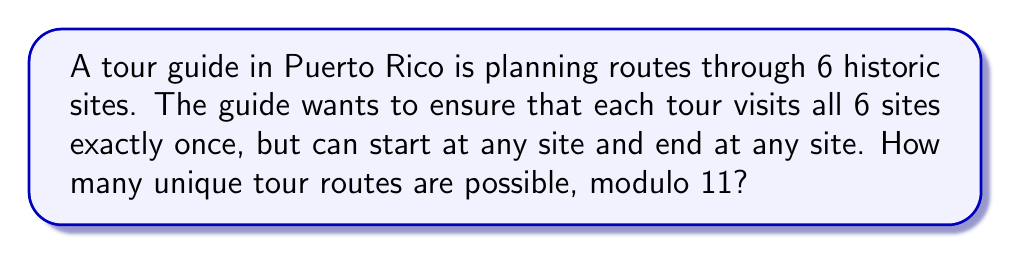Can you solve this math problem? Let's approach this step-by-step:

1) First, we need to calculate the total number of possible routes without considering the modulo:

   - There are 6! ways to arrange 6 sites in a line.
   - However, since the tour can start at any site, we need to divide by 6 (as each unique tour is counted 6 times, once starting from each site).

   So, the total number of unique routes is: $\frac{6!}{6} = 5!$

2) Now, let's calculate 5!:

   $5! = 5 \times 4 \times 3 \times 2 \times 1 = 120$

3) The question asks for the result modulo 11. In modular arithmetic, this is equivalent to finding the remainder when 120 is divided by 11.

4) We can use the division algorithm:

   $120 = 10 \times 11 + 10$

5) Therefore, 120 ≡ 10 (mod 11)

This means that the number of unique tour routes, when considered modulo 11, is 10.
Answer: 10 